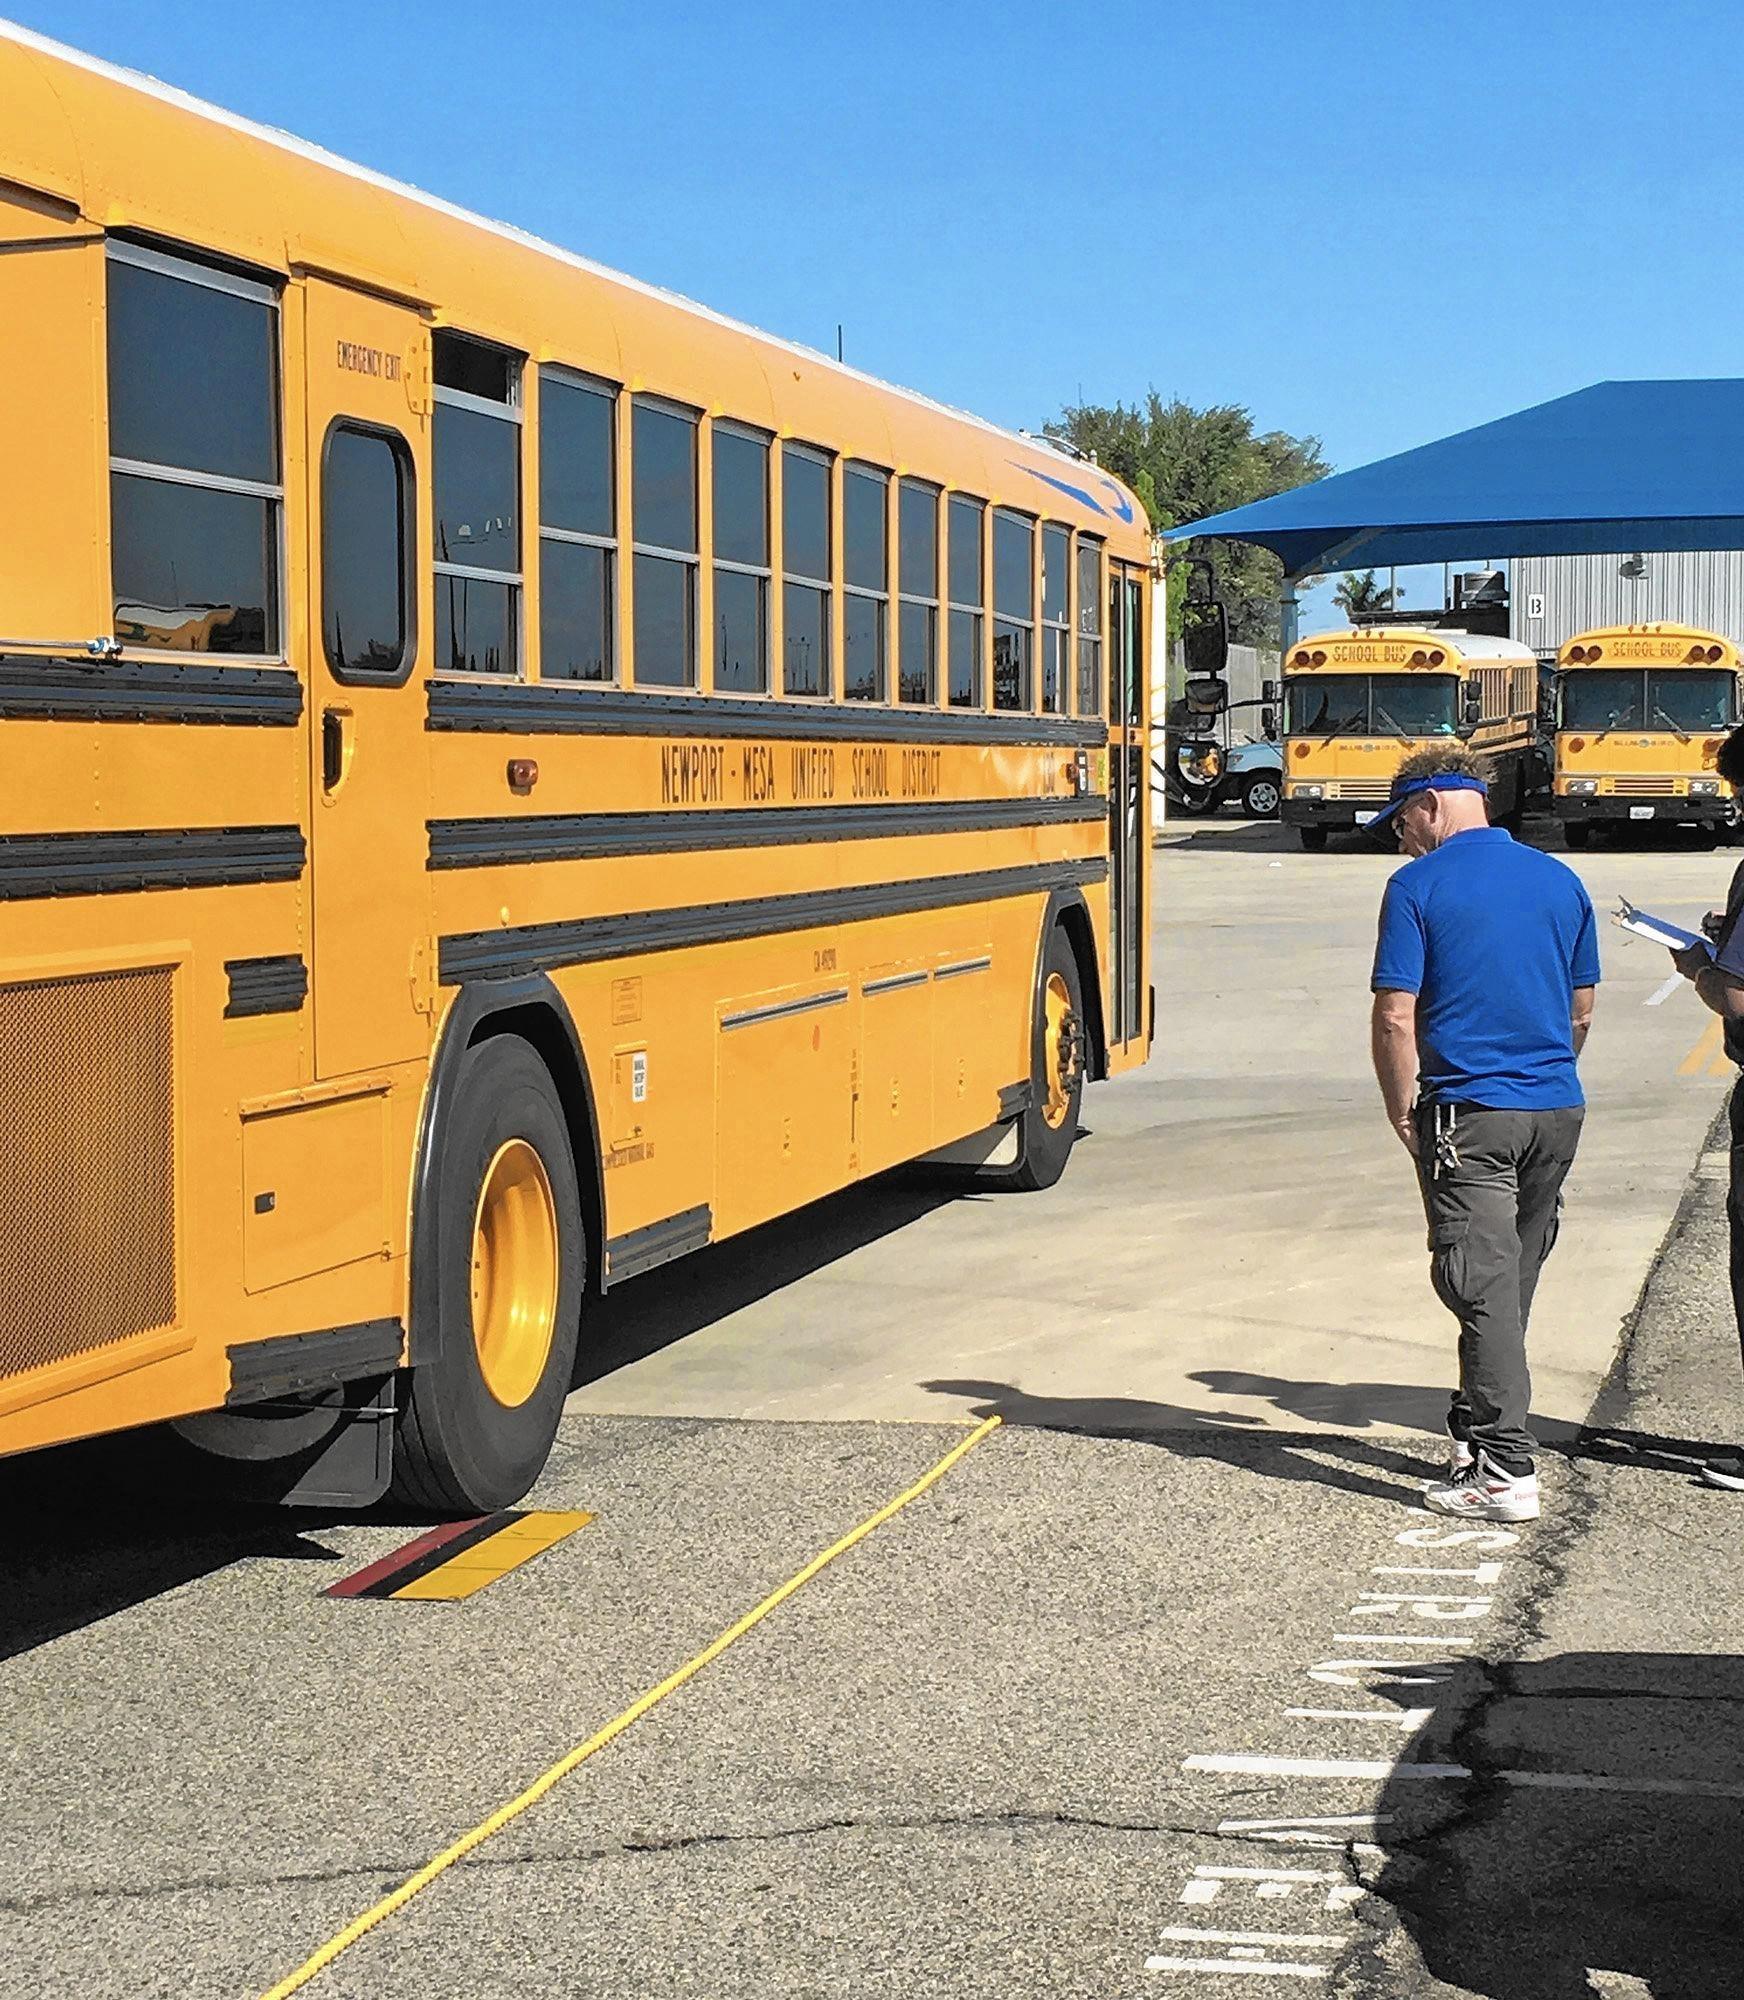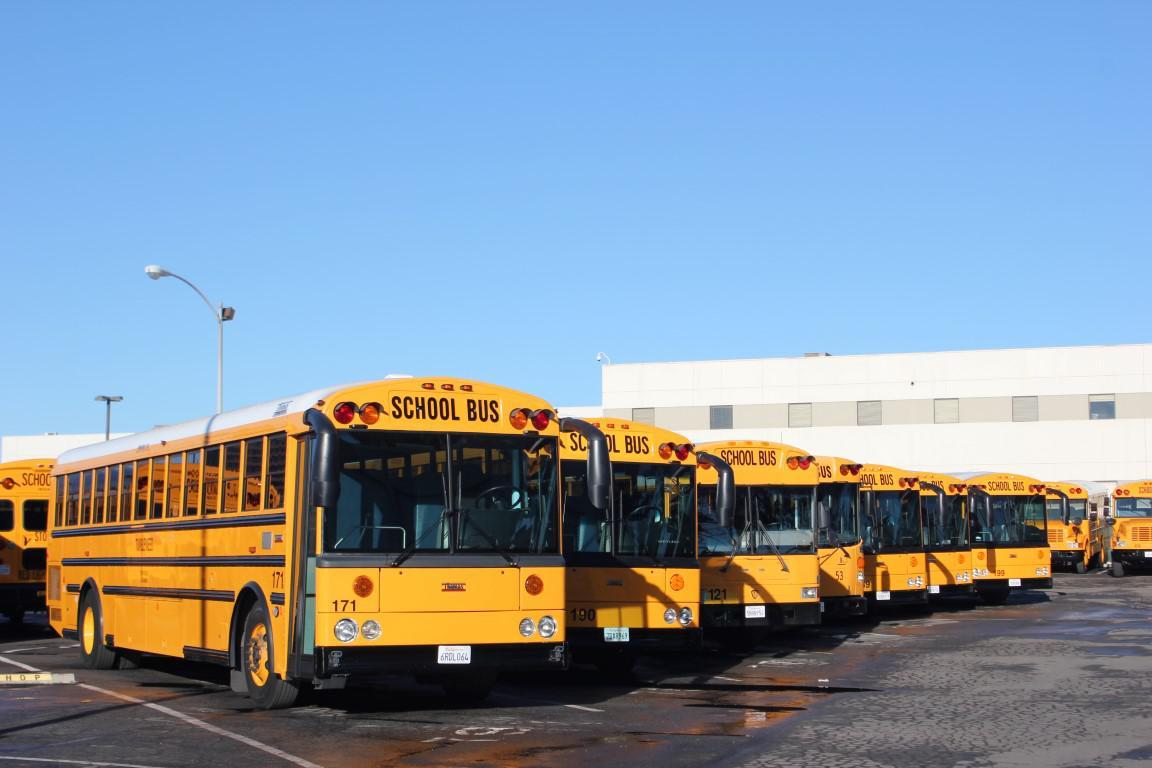The first image is the image on the left, the second image is the image on the right. Considering the images on both sides, is "A bus' passenger door is visible." valid? Answer yes or no. Yes. The first image is the image on the left, the second image is the image on the right. Assess this claim about the two images: "The buses on the right are parked in a row and facing toward the camera.". Correct or not? Answer yes or no. Yes. 